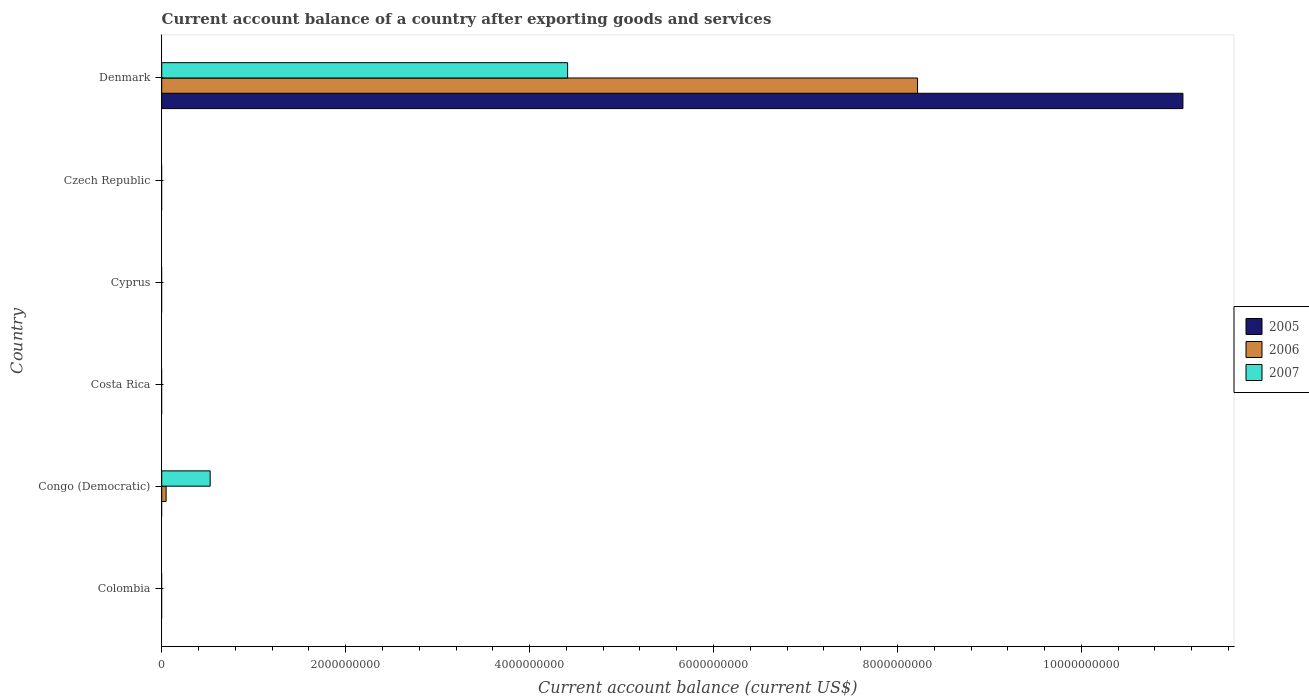How many different coloured bars are there?
Keep it short and to the point. 3. Are the number of bars on each tick of the Y-axis equal?
Ensure brevity in your answer.  No. How many bars are there on the 3rd tick from the top?
Provide a short and direct response. 0. How many bars are there on the 1st tick from the bottom?
Give a very brief answer. 0. What is the label of the 5th group of bars from the top?
Make the answer very short. Congo (Democratic). In how many cases, is the number of bars for a given country not equal to the number of legend labels?
Your response must be concise. 5. Across all countries, what is the maximum account balance in 2007?
Your answer should be compact. 4.41e+09. Across all countries, what is the minimum account balance in 2007?
Offer a terse response. 0. What is the total account balance in 2006 in the graph?
Provide a short and direct response. 8.27e+09. What is the difference between the account balance in 2007 in Congo (Democratic) and that in Denmark?
Keep it short and to the point. -3.89e+09. What is the difference between the account balance in 2005 in Congo (Democratic) and the account balance in 2006 in Colombia?
Offer a terse response. 0. What is the average account balance in 2005 per country?
Your response must be concise. 1.85e+09. What is the difference between the account balance in 2007 and account balance in 2006 in Congo (Democratic)?
Ensure brevity in your answer.  4.79e+08. In how many countries, is the account balance in 2006 greater than 4800000000 US$?
Ensure brevity in your answer.  1. What is the difference between the highest and the lowest account balance in 2005?
Your response must be concise. 1.11e+1. Is it the case that in every country, the sum of the account balance in 2007 and account balance in 2006 is greater than the account balance in 2005?
Offer a very short reply. No. How many bars are there?
Offer a very short reply. 5. Are all the bars in the graph horizontal?
Offer a terse response. Yes. How many countries are there in the graph?
Keep it short and to the point. 6. What is the difference between two consecutive major ticks on the X-axis?
Provide a short and direct response. 2.00e+09. Are the values on the major ticks of X-axis written in scientific E-notation?
Offer a very short reply. No. Does the graph contain any zero values?
Ensure brevity in your answer.  Yes. Where does the legend appear in the graph?
Keep it short and to the point. Center right. How many legend labels are there?
Your answer should be very brief. 3. What is the title of the graph?
Provide a succinct answer. Current account balance of a country after exporting goods and services. What is the label or title of the X-axis?
Your response must be concise. Current account balance (current US$). What is the label or title of the Y-axis?
Provide a succinct answer. Country. What is the Current account balance (current US$) of 2006 in Colombia?
Keep it short and to the point. 0. What is the Current account balance (current US$) of 2007 in Colombia?
Provide a succinct answer. 0. What is the Current account balance (current US$) of 2006 in Congo (Democratic)?
Provide a short and direct response. 4.78e+07. What is the Current account balance (current US$) in 2007 in Congo (Democratic)?
Your response must be concise. 5.27e+08. What is the Current account balance (current US$) of 2005 in Costa Rica?
Your answer should be compact. 0. What is the Current account balance (current US$) of 2006 in Cyprus?
Your answer should be very brief. 0. What is the Current account balance (current US$) in 2007 in Cyprus?
Provide a succinct answer. 0. What is the Current account balance (current US$) in 2005 in Czech Republic?
Keep it short and to the point. 0. What is the Current account balance (current US$) of 2005 in Denmark?
Keep it short and to the point. 1.11e+1. What is the Current account balance (current US$) of 2006 in Denmark?
Offer a very short reply. 8.22e+09. What is the Current account balance (current US$) in 2007 in Denmark?
Make the answer very short. 4.41e+09. Across all countries, what is the maximum Current account balance (current US$) in 2005?
Give a very brief answer. 1.11e+1. Across all countries, what is the maximum Current account balance (current US$) in 2006?
Make the answer very short. 8.22e+09. Across all countries, what is the maximum Current account balance (current US$) in 2007?
Give a very brief answer. 4.41e+09. Across all countries, what is the minimum Current account balance (current US$) of 2006?
Make the answer very short. 0. What is the total Current account balance (current US$) of 2005 in the graph?
Keep it short and to the point. 1.11e+1. What is the total Current account balance (current US$) in 2006 in the graph?
Make the answer very short. 8.27e+09. What is the total Current account balance (current US$) of 2007 in the graph?
Make the answer very short. 4.94e+09. What is the difference between the Current account balance (current US$) in 2006 in Congo (Democratic) and that in Denmark?
Your answer should be very brief. -8.17e+09. What is the difference between the Current account balance (current US$) of 2007 in Congo (Democratic) and that in Denmark?
Keep it short and to the point. -3.89e+09. What is the difference between the Current account balance (current US$) of 2006 in Congo (Democratic) and the Current account balance (current US$) of 2007 in Denmark?
Your answer should be very brief. -4.37e+09. What is the average Current account balance (current US$) in 2005 per country?
Your response must be concise. 1.85e+09. What is the average Current account balance (current US$) in 2006 per country?
Provide a short and direct response. 1.38e+09. What is the average Current account balance (current US$) in 2007 per country?
Give a very brief answer. 8.23e+08. What is the difference between the Current account balance (current US$) in 2006 and Current account balance (current US$) in 2007 in Congo (Democratic)?
Offer a terse response. -4.79e+08. What is the difference between the Current account balance (current US$) in 2005 and Current account balance (current US$) in 2006 in Denmark?
Your answer should be compact. 2.89e+09. What is the difference between the Current account balance (current US$) in 2005 and Current account balance (current US$) in 2007 in Denmark?
Your response must be concise. 6.69e+09. What is the difference between the Current account balance (current US$) of 2006 and Current account balance (current US$) of 2007 in Denmark?
Offer a terse response. 3.80e+09. What is the ratio of the Current account balance (current US$) of 2006 in Congo (Democratic) to that in Denmark?
Provide a succinct answer. 0.01. What is the ratio of the Current account balance (current US$) in 2007 in Congo (Democratic) to that in Denmark?
Make the answer very short. 0.12. What is the difference between the highest and the lowest Current account balance (current US$) of 2005?
Your answer should be compact. 1.11e+1. What is the difference between the highest and the lowest Current account balance (current US$) in 2006?
Your answer should be compact. 8.22e+09. What is the difference between the highest and the lowest Current account balance (current US$) in 2007?
Give a very brief answer. 4.41e+09. 